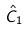<formula> <loc_0><loc_0><loc_500><loc_500>\hat { C } _ { 1 }</formula> 